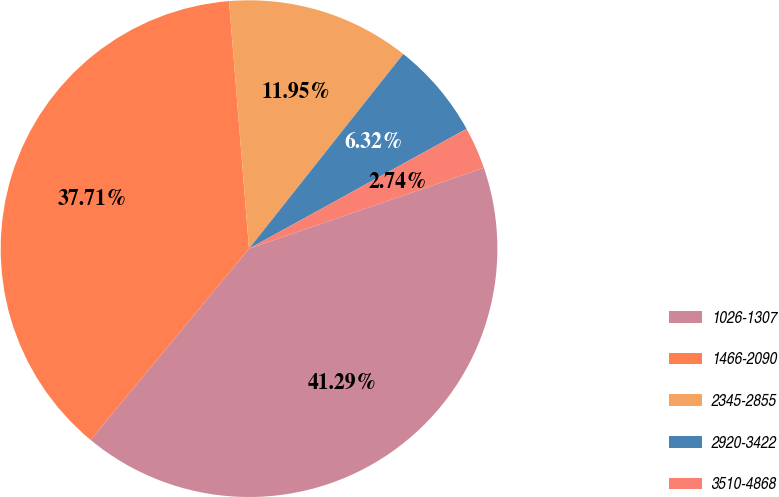<chart> <loc_0><loc_0><loc_500><loc_500><pie_chart><fcel>1026-1307<fcel>1466-2090<fcel>2345-2855<fcel>2920-3422<fcel>3510-4868<nl><fcel>41.29%<fcel>37.71%<fcel>11.95%<fcel>6.32%<fcel>2.74%<nl></chart> 